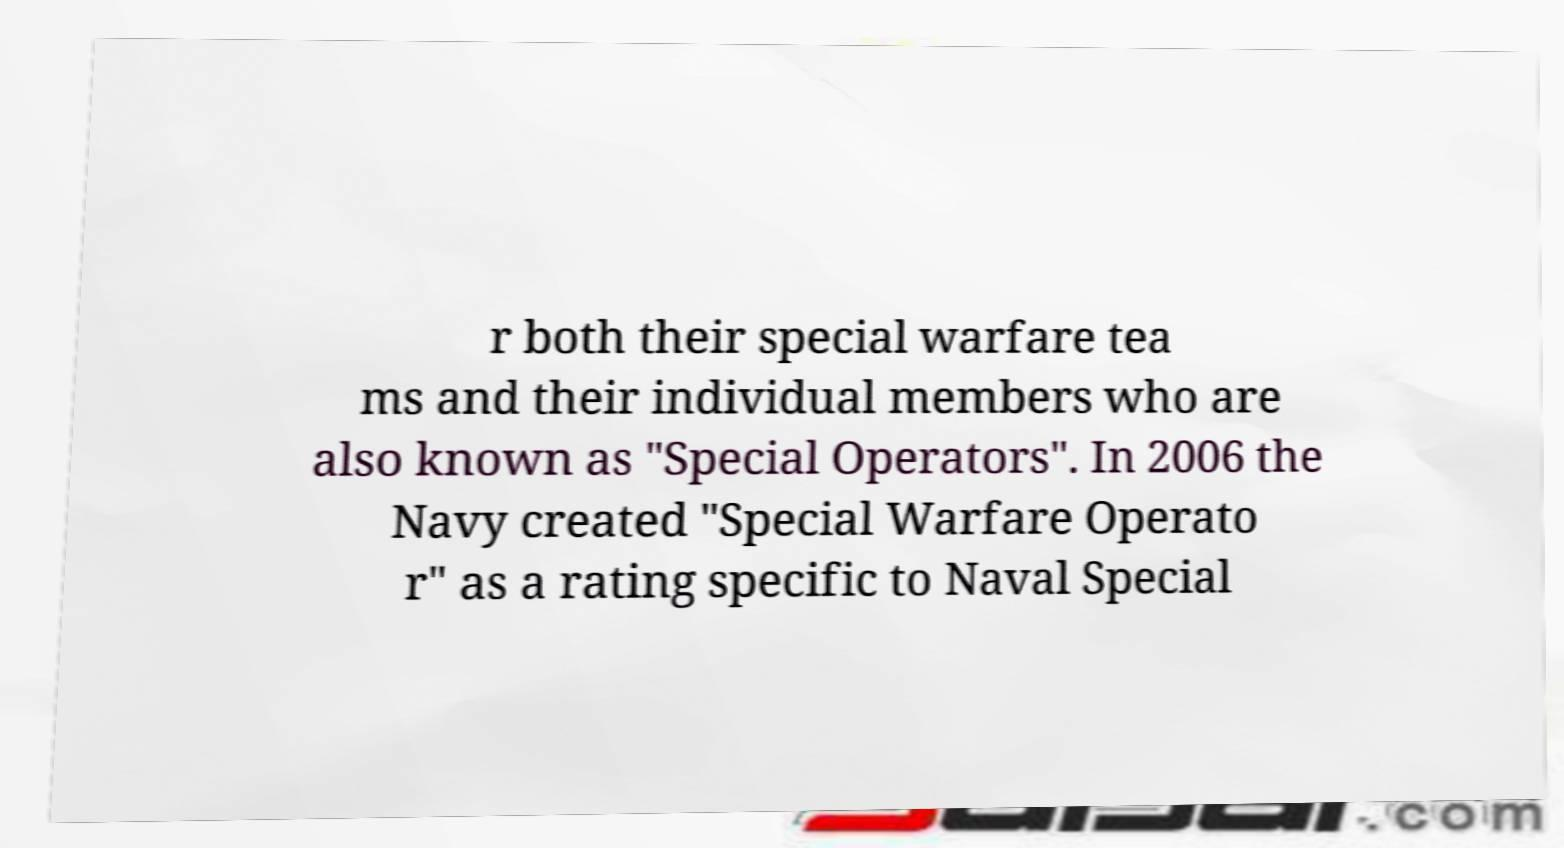Can you accurately transcribe the text from the provided image for me? r both their special warfare tea ms and their individual members who are also known as "Special Operators". In 2006 the Navy created "Special Warfare Operato r" as a rating specific to Naval Special 